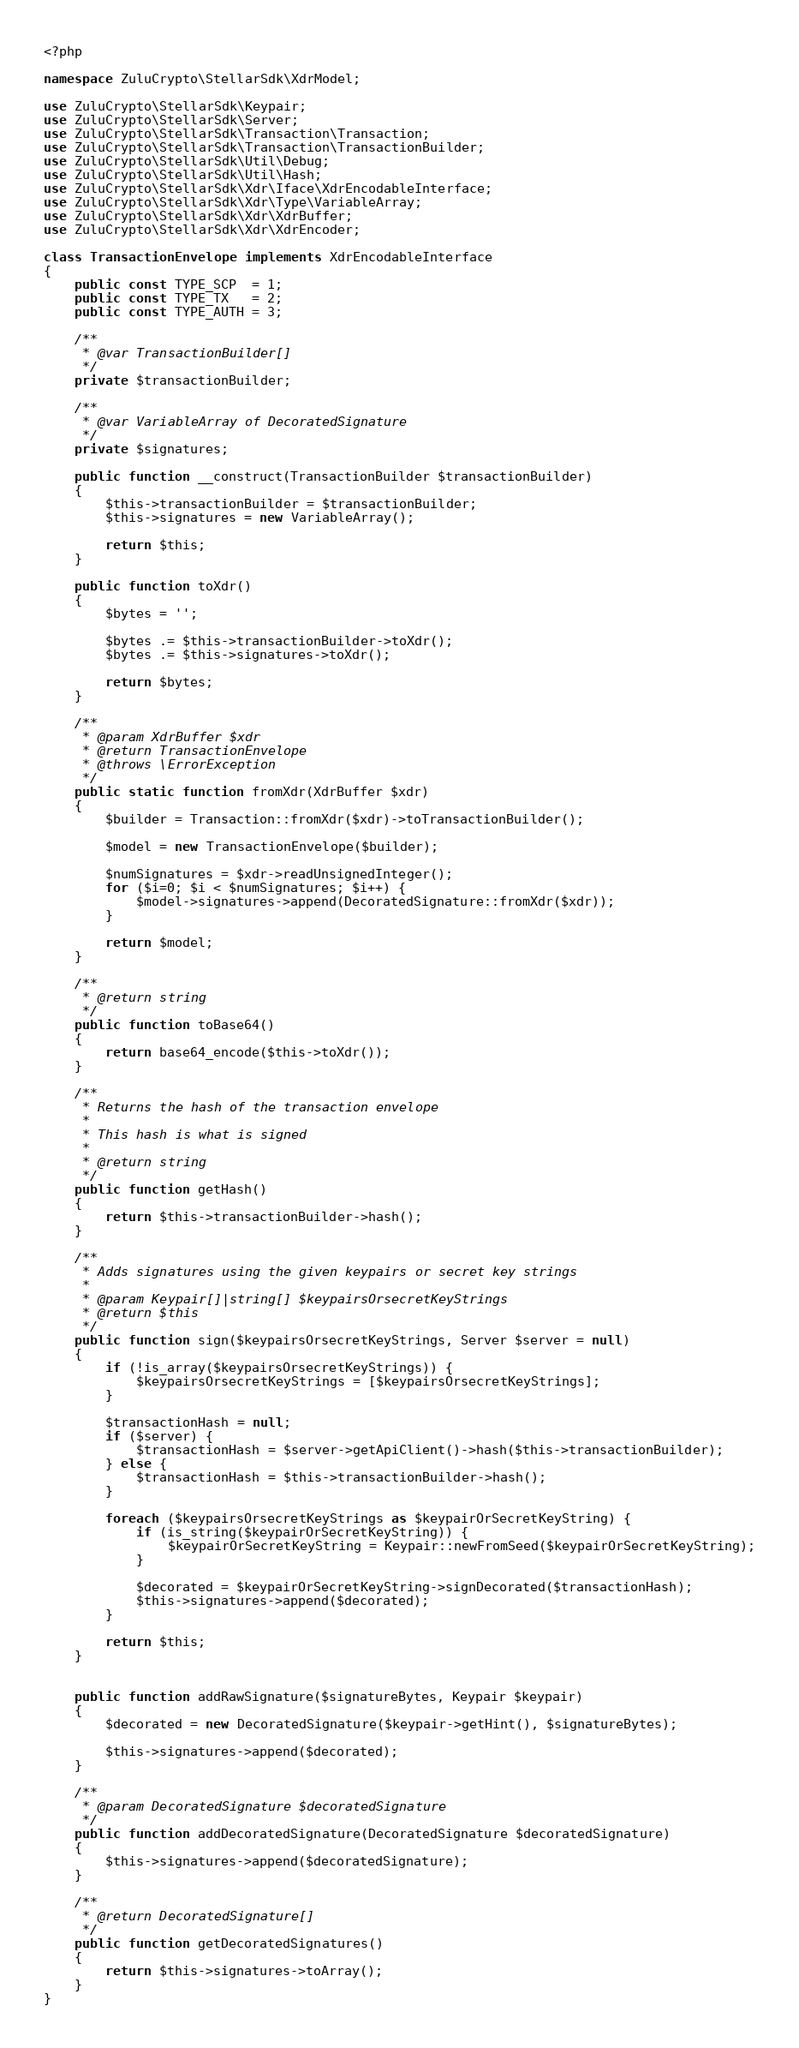Convert code to text. <code><loc_0><loc_0><loc_500><loc_500><_PHP_><?php

namespace ZuluCrypto\StellarSdk\XdrModel;

use ZuluCrypto\StellarSdk\Keypair;
use ZuluCrypto\StellarSdk\Server;
use ZuluCrypto\StellarSdk\Transaction\Transaction;
use ZuluCrypto\StellarSdk\Transaction\TransactionBuilder;
use ZuluCrypto\StellarSdk\Util\Debug;
use ZuluCrypto\StellarSdk\Util\Hash;
use ZuluCrypto\StellarSdk\Xdr\Iface\XdrEncodableInterface;
use ZuluCrypto\StellarSdk\Xdr\Type\VariableArray;
use ZuluCrypto\StellarSdk\Xdr\XdrBuffer;
use ZuluCrypto\StellarSdk\Xdr\XdrEncoder;

class TransactionEnvelope implements XdrEncodableInterface
{
    public const TYPE_SCP  = 1;
    public const TYPE_TX   = 2;
    public const TYPE_AUTH = 3;

    /**
     * @var TransactionBuilder[]
     */
    private $transactionBuilder;

    /**
     * @var VariableArray of DecoratedSignature
     */
    private $signatures;

    public function __construct(TransactionBuilder $transactionBuilder)
    {
        $this->transactionBuilder = $transactionBuilder;
        $this->signatures = new VariableArray();

        return $this;
    }

    public function toXdr()
    {
        $bytes = '';

        $bytes .= $this->transactionBuilder->toXdr();
        $bytes .= $this->signatures->toXdr();

        return $bytes;
    }

    /**
     * @param XdrBuffer $xdr
     * @return TransactionEnvelope
     * @throws \ErrorException
     */
    public static function fromXdr(XdrBuffer $xdr)
    {
        $builder = Transaction::fromXdr($xdr)->toTransactionBuilder();

        $model = new TransactionEnvelope($builder);

        $numSignatures = $xdr->readUnsignedInteger();
        for ($i=0; $i < $numSignatures; $i++) {
            $model->signatures->append(DecoratedSignature::fromXdr($xdr));
        }

        return $model;
    }

    /**
     * @return string
     */
    public function toBase64()
    {
        return base64_encode($this->toXdr());
    }

    /**
     * Returns the hash of the transaction envelope
     *
     * This hash is what is signed
     *
     * @return string
     */
    public function getHash()
    {
        return $this->transactionBuilder->hash();
    }

    /**
     * Adds signatures using the given keypairs or secret key strings
     *
     * @param Keypair[]|string[] $keypairsOrsecretKeyStrings
     * @return $this
     */
    public function sign($keypairsOrsecretKeyStrings, Server $server = null)
    {
        if (!is_array($keypairsOrsecretKeyStrings)) {
            $keypairsOrsecretKeyStrings = [$keypairsOrsecretKeyStrings];
        }

        $transactionHash = null;
        if ($server) {
            $transactionHash = $server->getApiClient()->hash($this->transactionBuilder);
        } else {
            $transactionHash = $this->transactionBuilder->hash();
        }

        foreach ($keypairsOrsecretKeyStrings as $keypairOrSecretKeyString) {
            if (is_string($keypairOrSecretKeyString)) {
                $keypairOrSecretKeyString = Keypair::newFromSeed($keypairOrSecretKeyString);
            }

            $decorated = $keypairOrSecretKeyString->signDecorated($transactionHash);
            $this->signatures->append($decorated);
        }

        return $this;
    }


    public function addRawSignature($signatureBytes, Keypair $keypair)
    {
        $decorated = new DecoratedSignature($keypair->getHint(), $signatureBytes);

        $this->signatures->append($decorated);
    }

    /**
     * @param DecoratedSignature $decoratedSignature
     */
    public function addDecoratedSignature(DecoratedSignature $decoratedSignature)
    {
        $this->signatures->append($decoratedSignature);
    }

    /**
     * @return DecoratedSignature[]
     */
    public function getDecoratedSignatures()
    {
        return $this->signatures->toArray();
    }
}
</code> 